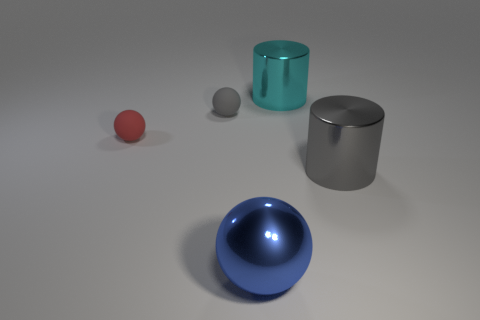Add 2 tiny gray spheres. How many objects exist? 7 Subtract all cylinders. How many objects are left? 3 Subtract all gray balls. Subtract all small red balls. How many objects are left? 3 Add 5 gray rubber spheres. How many gray rubber spheres are left? 6 Add 4 large gray things. How many large gray things exist? 5 Subtract 0 purple spheres. How many objects are left? 5 